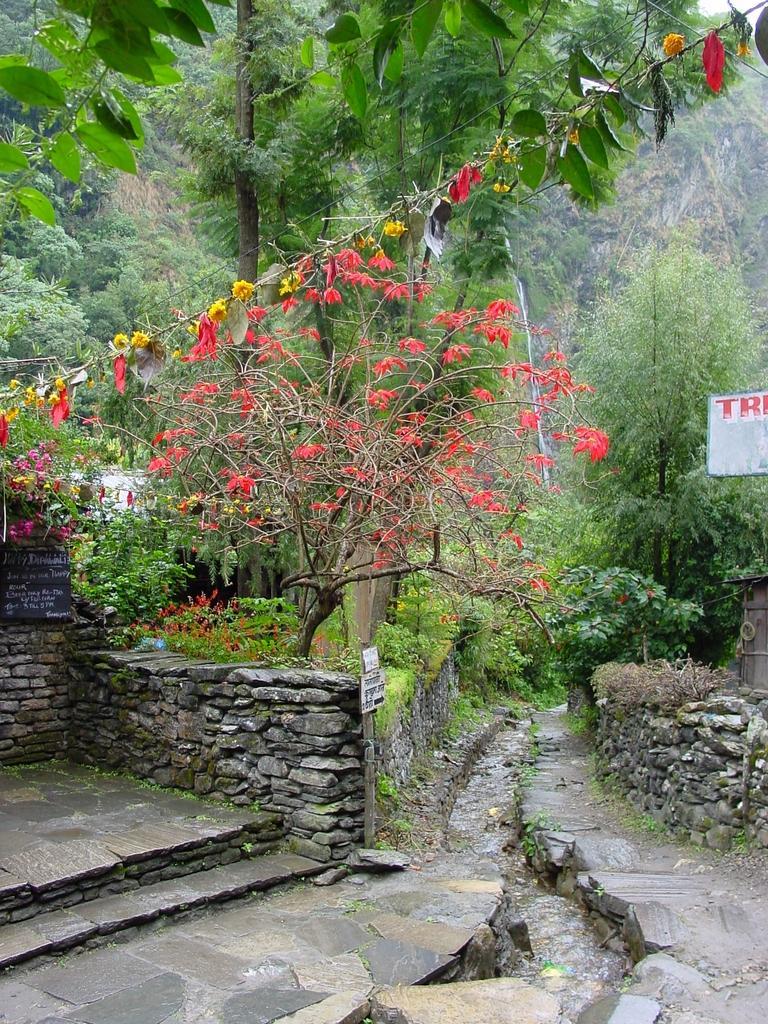Could you give a brief overview of what you see in this image? In this image I can see the ground, the water, few walls which are made up of rocks, few poles, few boards and few trees which are green and red in color. In the background I can see few trees and the sky. 